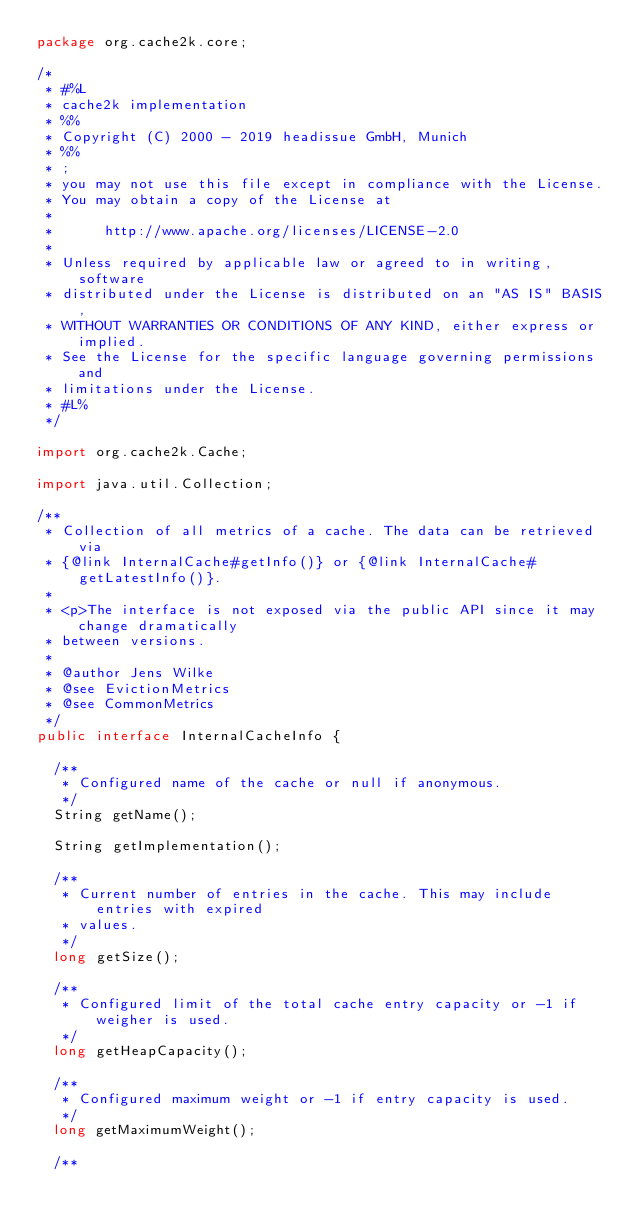<code> <loc_0><loc_0><loc_500><loc_500><_Java_>package org.cache2k.core;

/*
 * #%L
 * cache2k implementation
 * %%
 * Copyright (C) 2000 - 2019 headissue GmbH, Munich
 * %%
 * ;
 * you may not use this file except in compliance with the License.
 * You may obtain a copy of the License at
 * 
 *      http://www.apache.org/licenses/LICENSE-2.0
 * 
 * Unless required by applicable law or agreed to in writing, software
 * distributed under the License is distributed on an "AS IS" BASIS,
 * WITHOUT WARRANTIES OR CONDITIONS OF ANY KIND, either express or implied.
 * See the License for the specific language governing permissions and
 * limitations under the License.
 * #L%
 */

import org.cache2k.Cache;

import java.util.Collection;

/**
 * Collection of all metrics of a cache. The data can be retrieved via
 * {@link InternalCache#getInfo()} or {@link InternalCache#getLatestInfo()}.
 *
 * <p>The interface is not exposed via the public API since it may change dramatically
 * between versions.
 *
 * @author Jens Wilke
 * @see EvictionMetrics
 * @see CommonMetrics
 */
public interface InternalCacheInfo {

  /**
   * Configured name of the cache or null if anonymous.
   */
  String getName();

  String getImplementation();

  /**
   * Current number of entries in the cache. This may include entries with expired
   * values.
   */
  long getSize();

  /**
   * Configured limit of the total cache entry capacity or -1 if weigher is used.
   */
  long getHeapCapacity();

  /**
   * Configured maximum weight or -1 if entry capacity is used.
   */
  long getMaximumWeight();

  /**</code> 